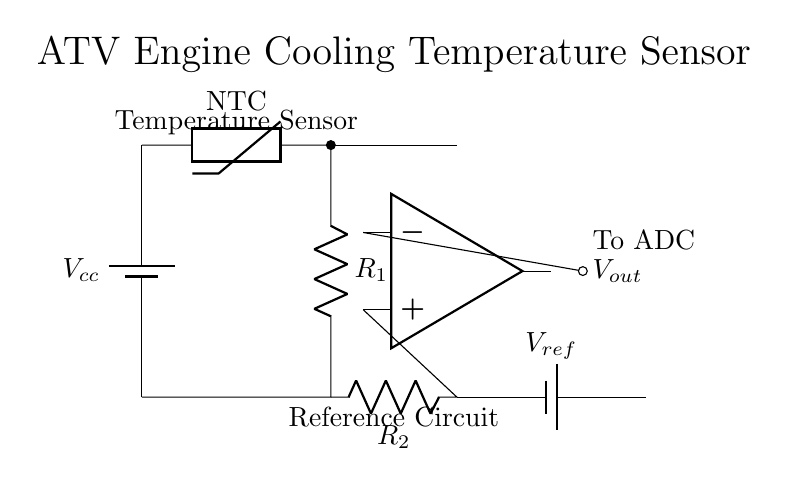What type of sensor is used in this circuit? The circuit uses a thermistor, which is indicated in the diagram as an NTC (negative temperature coefficient) sensor. This type of sensor decreases its resistance as the temperature increases.
Answer: Thermistor What is the role of the operational amplifier? The operational amplifier amplifies the voltage difference between its input terminals to provide a usable output signal that can be interpreted by an ADC. In this circuit, it processes the voltage from the thermistor and the reference voltage.
Answer: Amplification What are the resistance values in this circuit? The circuit includes two resistors labeled R1 and R2; however, the specific values for these resistors are not given in the diagram.
Answer: Not specified Where is the reference voltage applied? The reference voltage is applied at the non-inverting input of the operational amplifier, which allows it to compare the voltage from the thermistor against this known reference.
Answer: Non-inverting input What is the output of this circuit? The output, labeled as Vout, is connected to the ADC, which will convert the analog signal representing the temperature into a digital format for further processing.
Answer: Vout What happens to the output voltage as temperature increases? As the temperature increases, the resistance of the thermistor decreases, which leads to an increase in the output voltage from the operational amplifier due to the relationship between the resistance change and the voltage divider effect.
Answer: Increases What type of circuit is illustrated here? This circuit is a temperature sensing circuit designed for monitoring engine cooling systems in ATVs, employing passive components to sense temperature and an operational amplifier to process the signal.
Answer: Temperature sensing circuit 